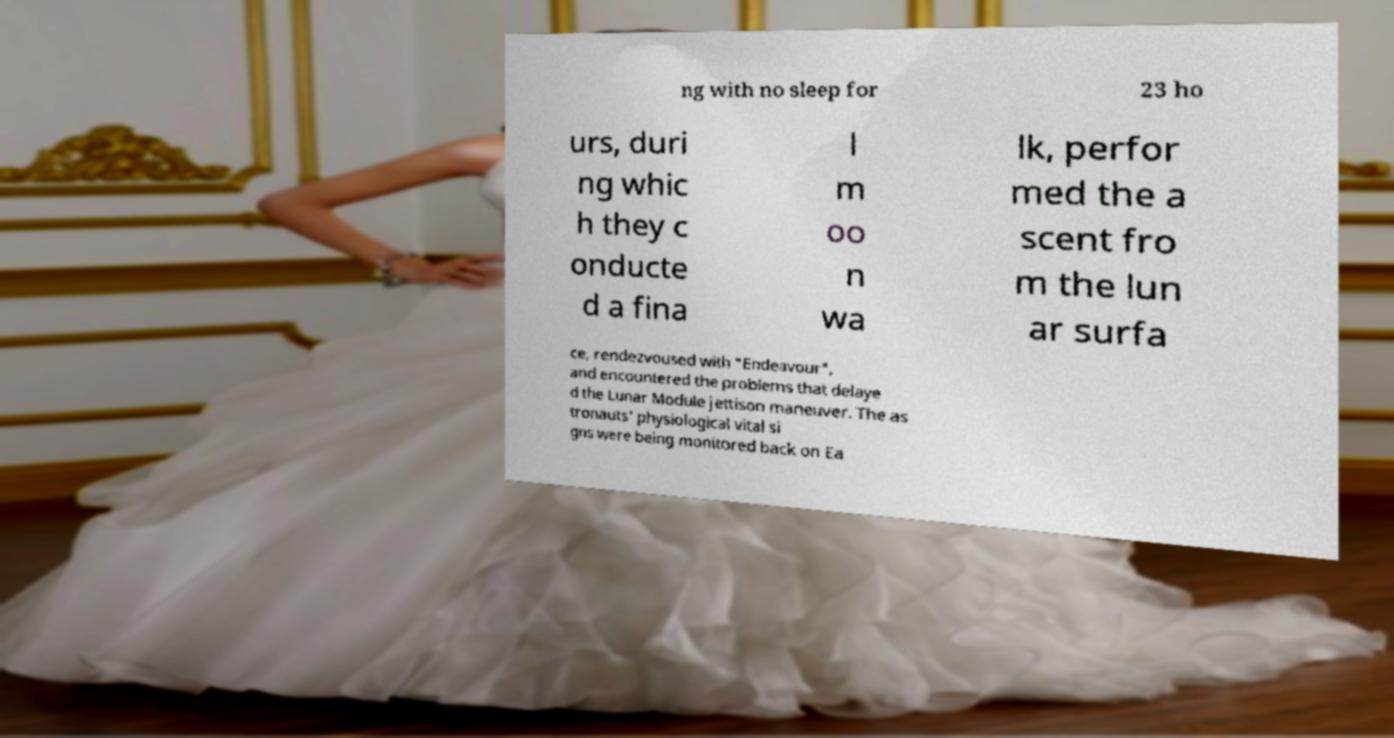Please read and relay the text visible in this image. What does it say? ng with no sleep for 23 ho urs, duri ng whic h they c onducte d a fina l m oo n wa lk, perfor med the a scent fro m the lun ar surfa ce, rendezvoused with "Endeavour", and encountered the problems that delaye d the Lunar Module jettison maneuver. The as tronauts' physiological vital si gns were being monitored back on Ea 